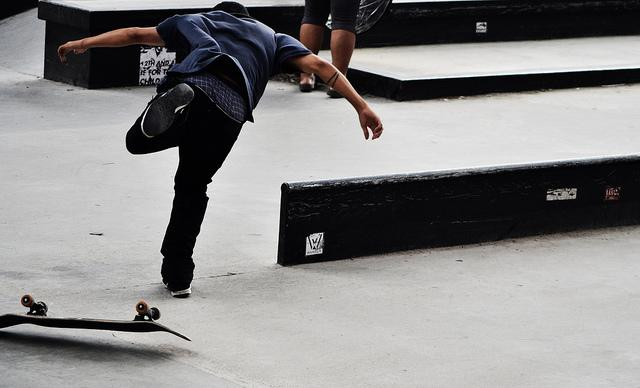How he is going to get hurt? falling 